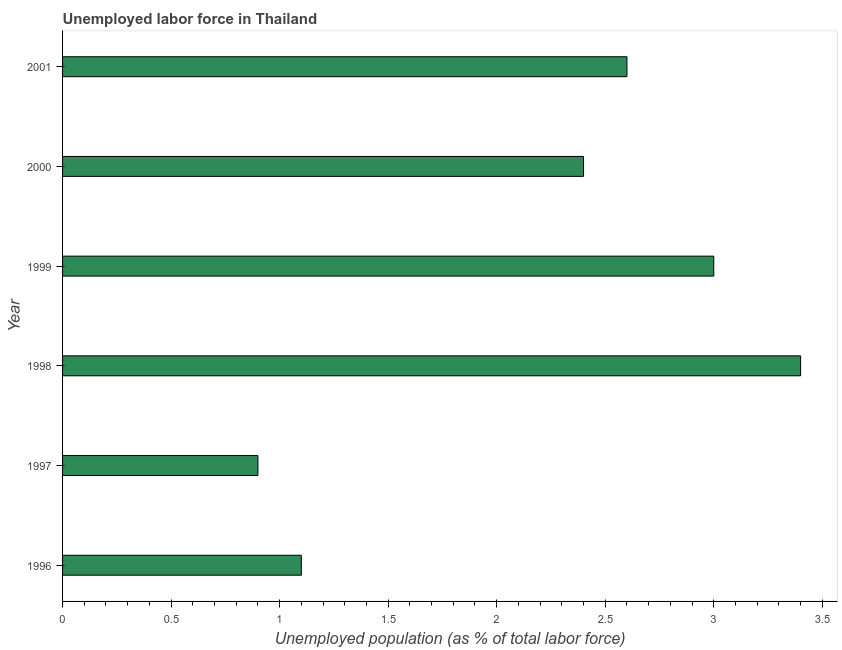Does the graph contain grids?
Your answer should be compact. No. What is the title of the graph?
Your answer should be compact. Unemployed labor force in Thailand. What is the label or title of the X-axis?
Your response must be concise. Unemployed population (as % of total labor force). What is the label or title of the Y-axis?
Provide a short and direct response. Year. What is the total unemployed population in 1997?
Give a very brief answer. 0.9. Across all years, what is the maximum total unemployed population?
Provide a short and direct response. 3.4. Across all years, what is the minimum total unemployed population?
Your response must be concise. 0.9. What is the sum of the total unemployed population?
Your answer should be compact. 13.4. What is the difference between the total unemployed population in 1996 and 1998?
Keep it short and to the point. -2.3. What is the average total unemployed population per year?
Make the answer very short. 2.23. What is the median total unemployed population?
Provide a short and direct response. 2.5. What is the ratio of the total unemployed population in 1999 to that in 2001?
Provide a short and direct response. 1.15. Is the total unemployed population in 1997 less than that in 2001?
Offer a very short reply. Yes. What is the difference between the highest and the second highest total unemployed population?
Ensure brevity in your answer.  0.4. Is the sum of the total unemployed population in 1996 and 1999 greater than the maximum total unemployed population across all years?
Provide a succinct answer. Yes. In how many years, is the total unemployed population greater than the average total unemployed population taken over all years?
Your answer should be very brief. 4. How many bars are there?
Your response must be concise. 6. What is the difference between two consecutive major ticks on the X-axis?
Ensure brevity in your answer.  0.5. Are the values on the major ticks of X-axis written in scientific E-notation?
Provide a succinct answer. No. What is the Unemployed population (as % of total labor force) in 1996?
Keep it short and to the point. 1.1. What is the Unemployed population (as % of total labor force) of 1997?
Offer a very short reply. 0.9. What is the Unemployed population (as % of total labor force) of 1998?
Make the answer very short. 3.4. What is the Unemployed population (as % of total labor force) of 2000?
Your answer should be compact. 2.4. What is the Unemployed population (as % of total labor force) of 2001?
Keep it short and to the point. 2.6. What is the difference between the Unemployed population (as % of total labor force) in 1996 and 1999?
Keep it short and to the point. -1.9. What is the difference between the Unemployed population (as % of total labor force) in 1996 and 2001?
Give a very brief answer. -1.5. What is the difference between the Unemployed population (as % of total labor force) in 1997 and 1998?
Offer a very short reply. -2.5. What is the difference between the Unemployed population (as % of total labor force) in 1997 and 2001?
Provide a short and direct response. -1.7. What is the difference between the Unemployed population (as % of total labor force) in 1998 and 1999?
Offer a very short reply. 0.4. What is the ratio of the Unemployed population (as % of total labor force) in 1996 to that in 1997?
Offer a very short reply. 1.22. What is the ratio of the Unemployed population (as % of total labor force) in 1996 to that in 1998?
Your response must be concise. 0.32. What is the ratio of the Unemployed population (as % of total labor force) in 1996 to that in 1999?
Your answer should be very brief. 0.37. What is the ratio of the Unemployed population (as % of total labor force) in 1996 to that in 2000?
Ensure brevity in your answer.  0.46. What is the ratio of the Unemployed population (as % of total labor force) in 1996 to that in 2001?
Provide a succinct answer. 0.42. What is the ratio of the Unemployed population (as % of total labor force) in 1997 to that in 1998?
Keep it short and to the point. 0.27. What is the ratio of the Unemployed population (as % of total labor force) in 1997 to that in 1999?
Provide a succinct answer. 0.3. What is the ratio of the Unemployed population (as % of total labor force) in 1997 to that in 2001?
Offer a terse response. 0.35. What is the ratio of the Unemployed population (as % of total labor force) in 1998 to that in 1999?
Offer a very short reply. 1.13. What is the ratio of the Unemployed population (as % of total labor force) in 1998 to that in 2000?
Give a very brief answer. 1.42. What is the ratio of the Unemployed population (as % of total labor force) in 1998 to that in 2001?
Ensure brevity in your answer.  1.31. What is the ratio of the Unemployed population (as % of total labor force) in 1999 to that in 2001?
Your answer should be compact. 1.15. What is the ratio of the Unemployed population (as % of total labor force) in 2000 to that in 2001?
Give a very brief answer. 0.92. 